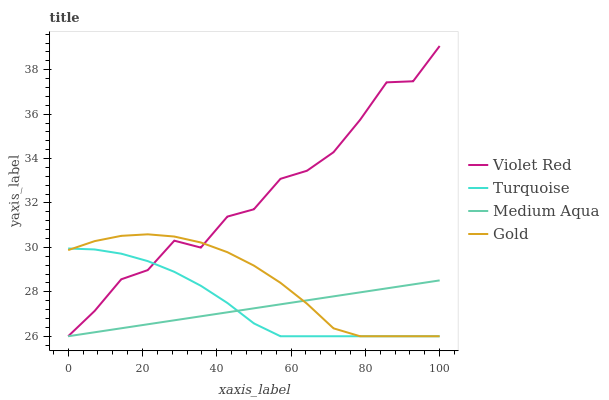Does Medium Aqua have the minimum area under the curve?
Answer yes or no. Yes. Does Violet Red have the maximum area under the curve?
Answer yes or no. Yes. Does Turquoise have the minimum area under the curve?
Answer yes or no. No. Does Turquoise have the maximum area under the curve?
Answer yes or no. No. Is Medium Aqua the smoothest?
Answer yes or no. Yes. Is Violet Red the roughest?
Answer yes or no. Yes. Is Turquoise the smoothest?
Answer yes or no. No. Is Turquoise the roughest?
Answer yes or no. No. Does Violet Red have the lowest value?
Answer yes or no. Yes. Does Violet Red have the highest value?
Answer yes or no. Yes. Does Turquoise have the highest value?
Answer yes or no. No. Does Turquoise intersect Medium Aqua?
Answer yes or no. Yes. Is Turquoise less than Medium Aqua?
Answer yes or no. No. Is Turquoise greater than Medium Aqua?
Answer yes or no. No. 